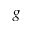Convert formula to latex. <formula><loc_0><loc_0><loc_500><loc_500>g</formula> 